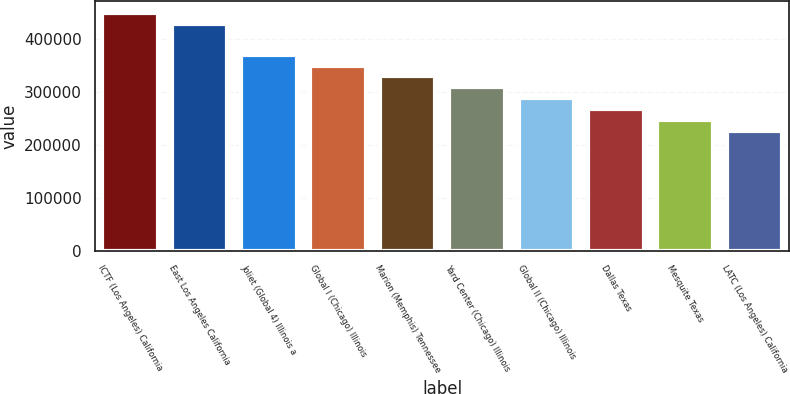Convert chart. <chart><loc_0><loc_0><loc_500><loc_500><bar_chart><fcel>ICTF (Los Angeles) California<fcel>East Los Angeles California<fcel>Joliet (Global 4) Illinois a<fcel>Global I (Chicago) Illinois<fcel>Marion (Memphis) Tennessee<fcel>Yard Center (Chicago) Illinois<fcel>Global II (Chicago) Illinois<fcel>Dallas Texas<fcel>Mesquite Texas<fcel>LATC (Los Angeles) California<nl><fcel>448600<fcel>428000<fcel>370200<fcel>349600<fcel>329000<fcel>308400<fcel>287800<fcel>267200<fcel>246600<fcel>226000<nl></chart> 